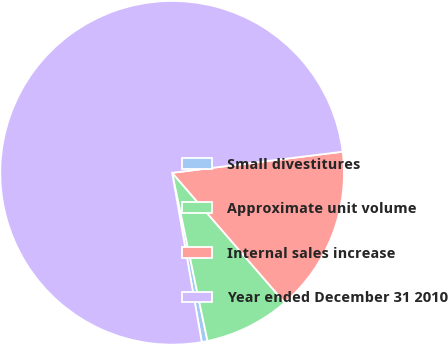Convert chart. <chart><loc_0><loc_0><loc_500><loc_500><pie_chart><fcel>Small divestitures<fcel>Approximate unit volume<fcel>Internal sales increase<fcel>Year ended December 31 2010<nl><fcel>0.54%<fcel>8.07%<fcel>15.59%<fcel>75.8%<nl></chart> 